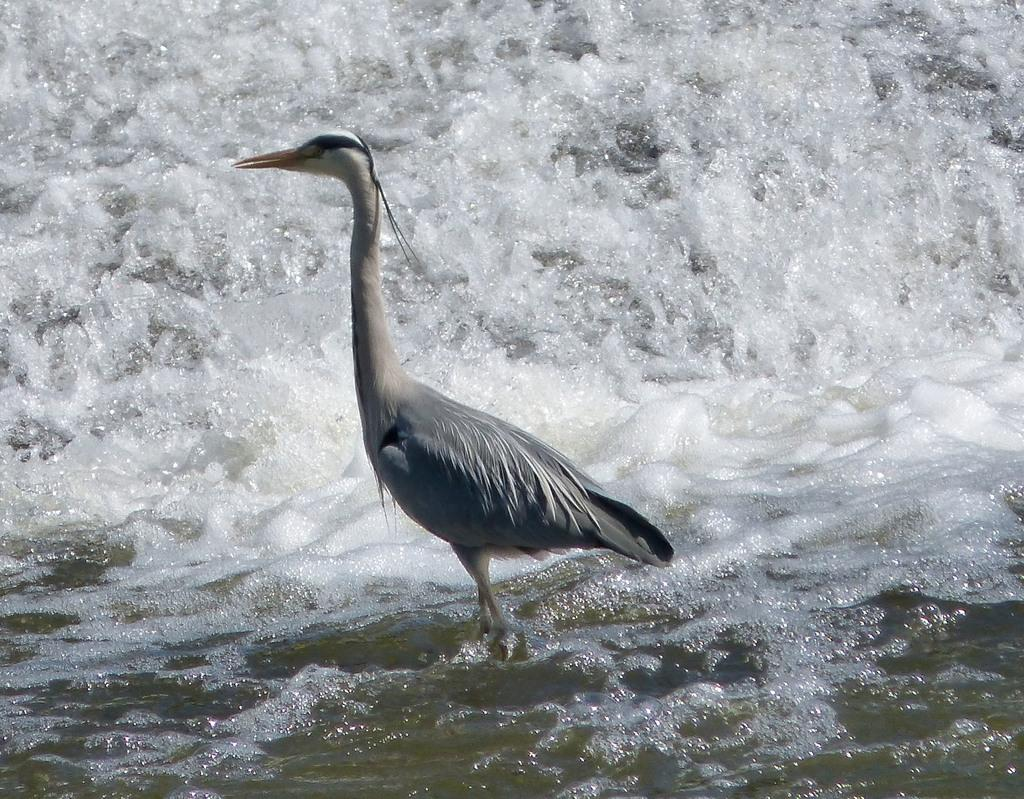What type of animal can be seen in the image? There is a bird in the image. Where is the bird located? The bird is in the water. What can be observed in the water around the bird? Waves are visible in the image. What color is the gold in the middle of the image? There is no gold present in the image. How does the bird blow bubbles in the water? The bird does not blow bubbles in the water; it is simply located in the water. 